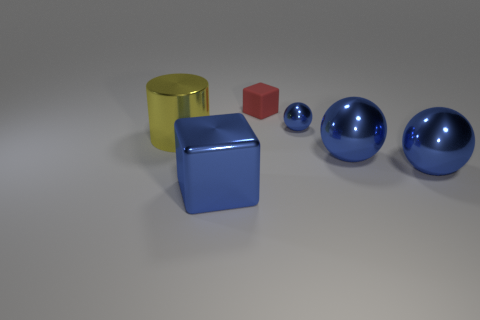Add 1 big blue things. How many objects exist? 7 Subtract all cubes. How many objects are left? 4 Subtract 0 brown balls. How many objects are left? 6 Subtract all yellow cylinders. Subtract all large purple objects. How many objects are left? 5 Add 2 blue metallic cubes. How many blue metallic cubes are left? 3 Add 1 tiny blue spheres. How many tiny blue spheres exist? 2 